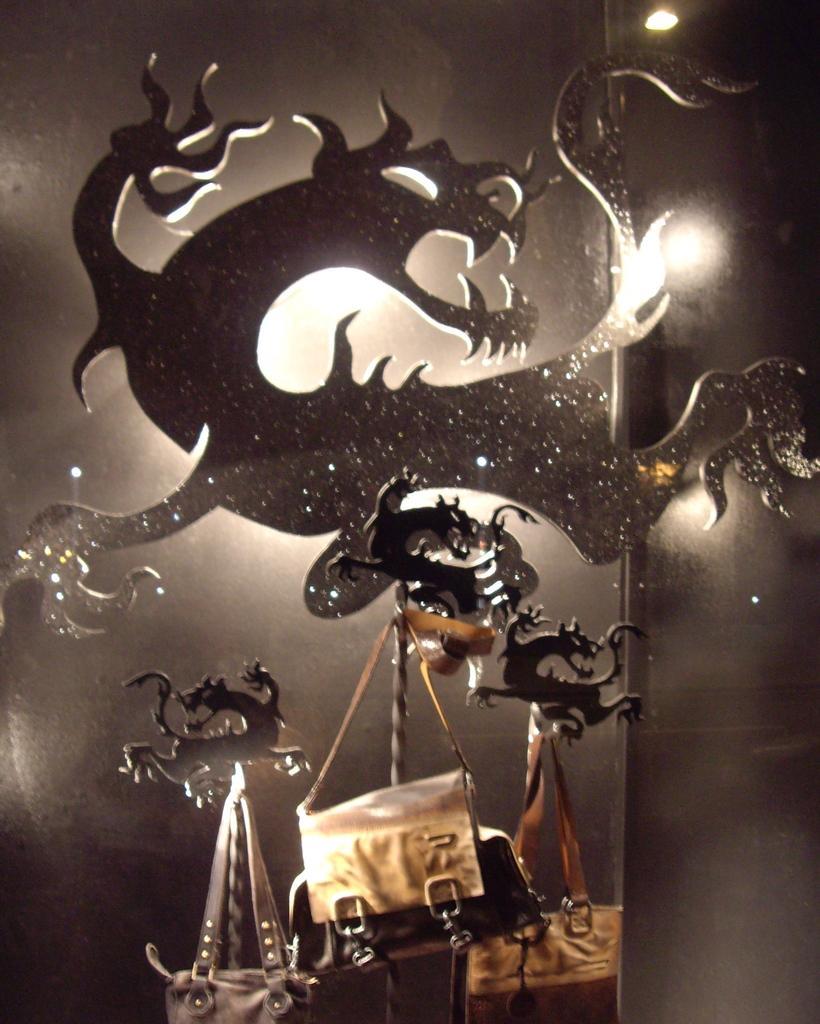Please provide a concise description of this image. This is the picture of a stand which is in dragon shape and there are some handbags Hanged to it. 